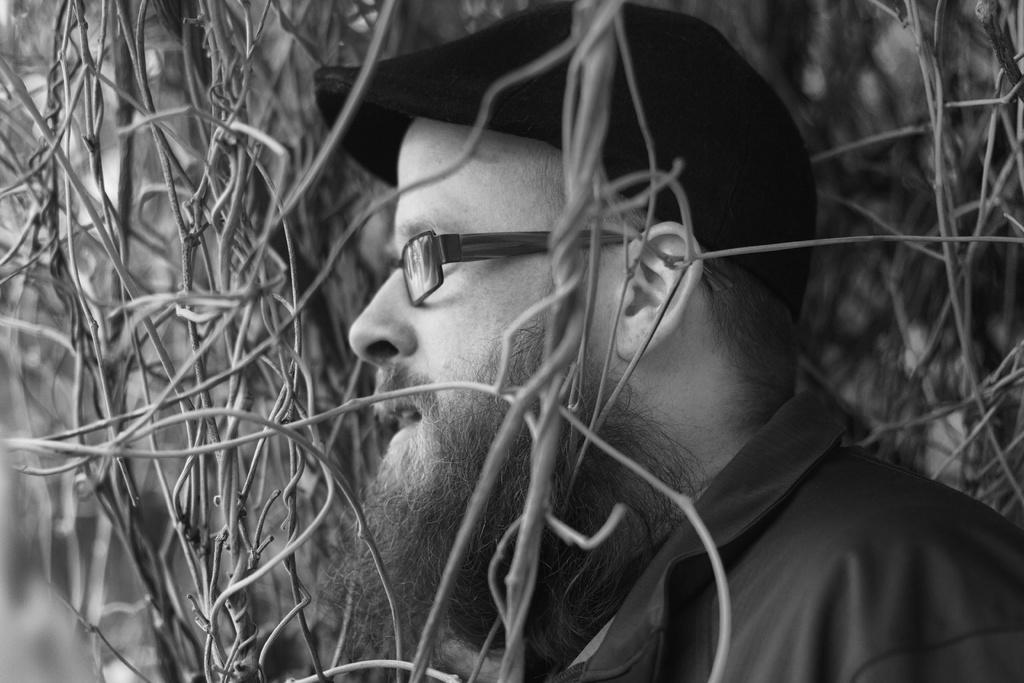What is the color scheme of the image? The image is black and white. Who is present in the image? There is a man in the image. What accessory is the man wearing? The man is wearing spectacles. What type of natural elements can be seen in the image? There are twigs visible in the image. What type of ship can be seen sailing in the image? There is no ship present in the image; it is a black and white image featuring a man wearing spectacles and twigs. 